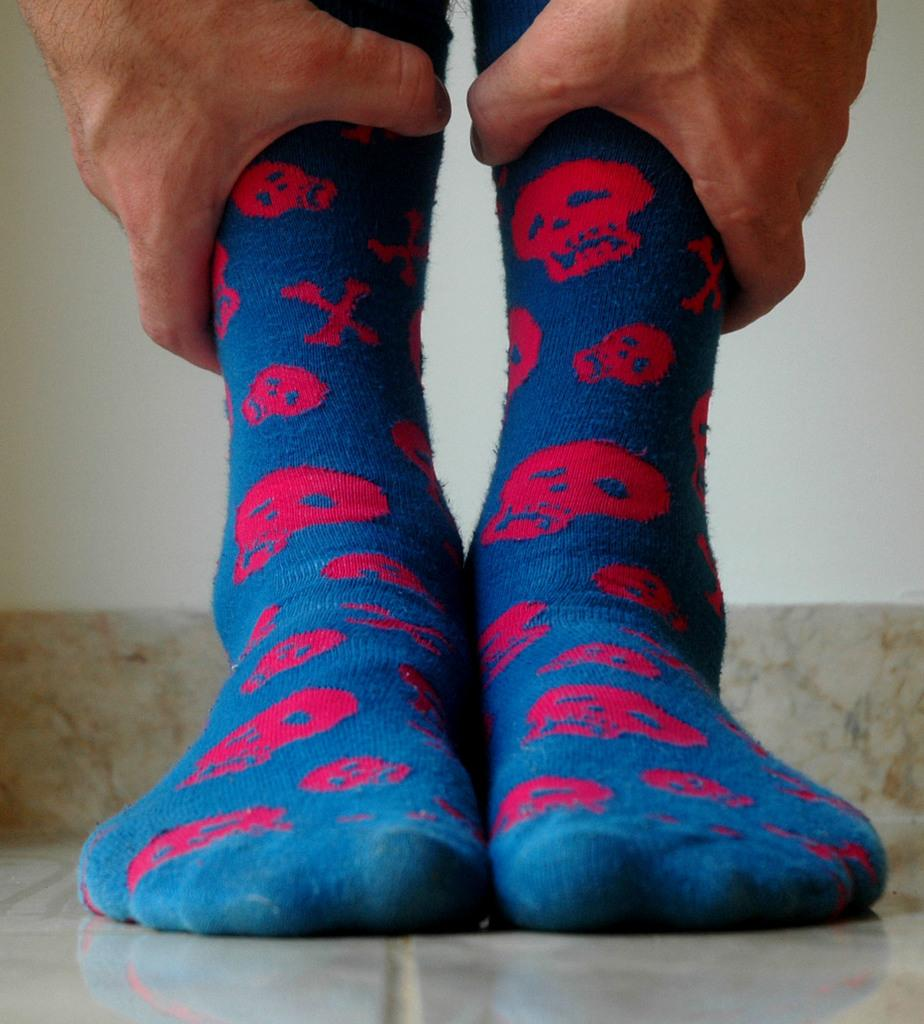What body parts are visible in the image? Legs and hands are visible in the image. What is the person doing with their legs in the image? The person is holding their legs in the image. What type of clothing is the person wearing on their feet? The person is wearing socks in the image. What type of magic is being performed with the salt in the image? There is no salt or magic present in the image; it only features a person holding their legs while wearing socks. 